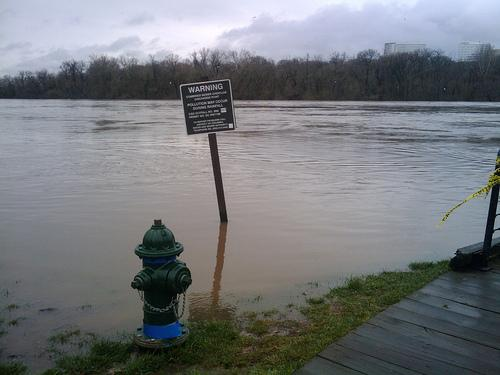Assess the overall quality of the image in terms of brightness, clarity, and color. The image has a moderate brightness level, a mix of clear and unclear elements, and a variety of colors like yellow, blue, green, and brown. How many fire hydrant-related objects are there in the image, and what are they? There are six fire hydrant-related objects: a blue band at the base of a hydrant, a metal chain on a fire hydrant, a green fire hydrant with blue paint on the bottom, a silver chain hanging from the fire hydrant, a blue paint on the green fire hydrant, and a reflection of the sign in the water. What kind of weather can be inferred from the image? The weather appears to be overcast, with dark rain clouds in the sky. List at least three objects that indicate human presence or activity. wet wooden deck, yellow caution tape, railing on dock Identify the condition of the water in the lake. The water in the lake is not clear and appears muddy. List all visible objects in the image. wet wooden deck, yellow caution tape, blue band on hydrant, metal chain on fire hydrant, brown lake, trees, dark rain clouds, green fire hydrant, silver chain, blue paint, warning sign, railing, reflection, muddy water, cloudy blue skies Identify any potential hazards or safety concerns in the image. The potential hazards in the image include the unclear, muddy water; the yellow caution tape; and the warning sign in the water. Analyze the potential sentiment or emotions that the image might evoke. The image might evoke emotions of unease, caution or worry due to the unclear water, caution tape, and warning sign. Describe any posted signs or caution elements visible in the image. A yellow caution tape wrapped around a pole, a black and white warning sign in the water, and a yellow and black tape hanging from the dock are visible in the image. Which of the ducks swimming in the lake is the largest? There is no mention of any ducks in the given captions. This instruction is misleading because it asks the reader to compare non-existent animals in the lake. What color is the umbrella near the railing on the dock? There is no mention of any umbrella in the given captions. This instruction is misleading because it assumes an object (the umbrella) that has not been mentioned exists in the image. Find the red hot air balloon floating above the trees. There is no mention of any hot air balloon in the given captions. This instruction is misleading because it asks the reader to search for a non-existent object in the sky. Identify which boat is sailing the fastest in the lake. There is no mention of any boats in the given captions. This instruction is misleading because it asks the reader to compare non-existent objects (boats) in the image. Search the image for a purple squirrel sitting on a bench. There is no mention of any bench or squirrel, let alone a purple squirrel, in any of the given captions. This instruction is misleading because it asks the reader to search for a non-existent object. Describe the graffiti on the wall beside the fire hydrant. There is no mention of any wall or graffiti in the given captions. This instruction is misleading because it assumes an object (the wall with graffiti) that has not been mentioned exists in the image. 